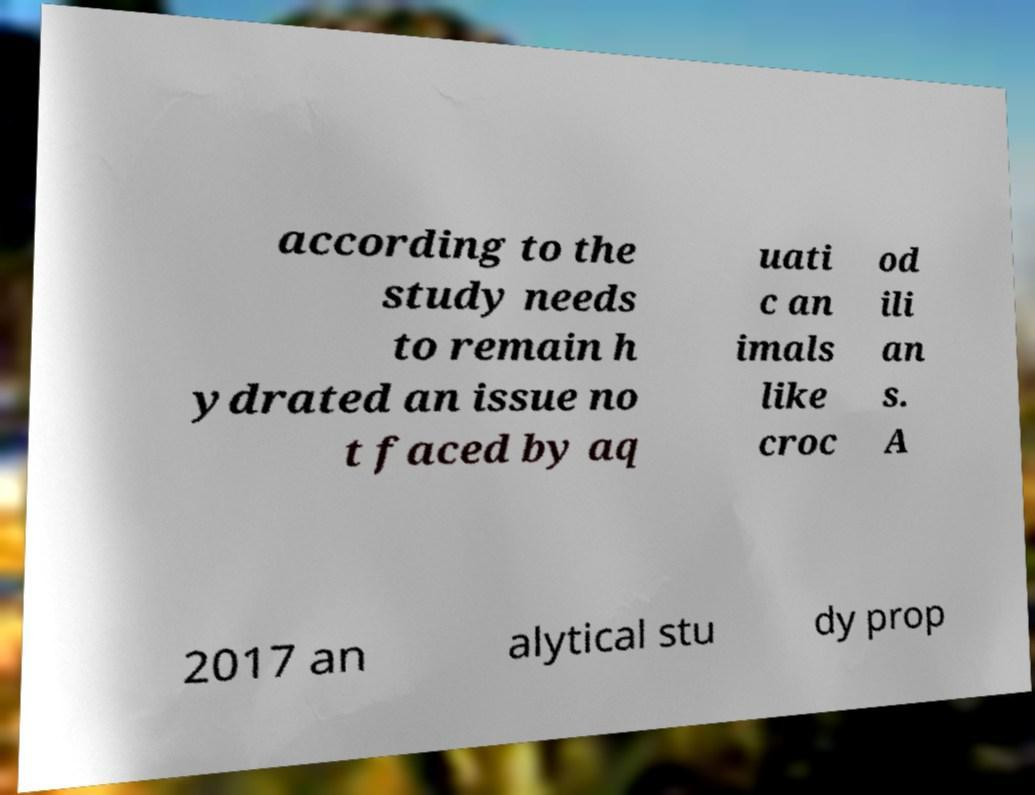There's text embedded in this image that I need extracted. Can you transcribe it verbatim? according to the study needs to remain h ydrated an issue no t faced by aq uati c an imals like croc od ili an s. A 2017 an alytical stu dy prop 